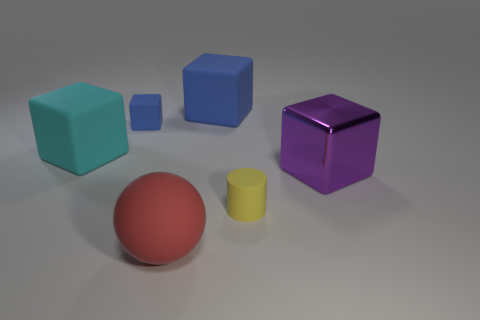Can you describe the shapes and colors of the objects in the image? Certainly! In the image, there are several geometric shapes. There's a teal cube, a smaller blue cube, and a small royal blue square. You'll also find a purple reflective cube and a red sphere. Lastly, there's a smaller yellow cylinder. 